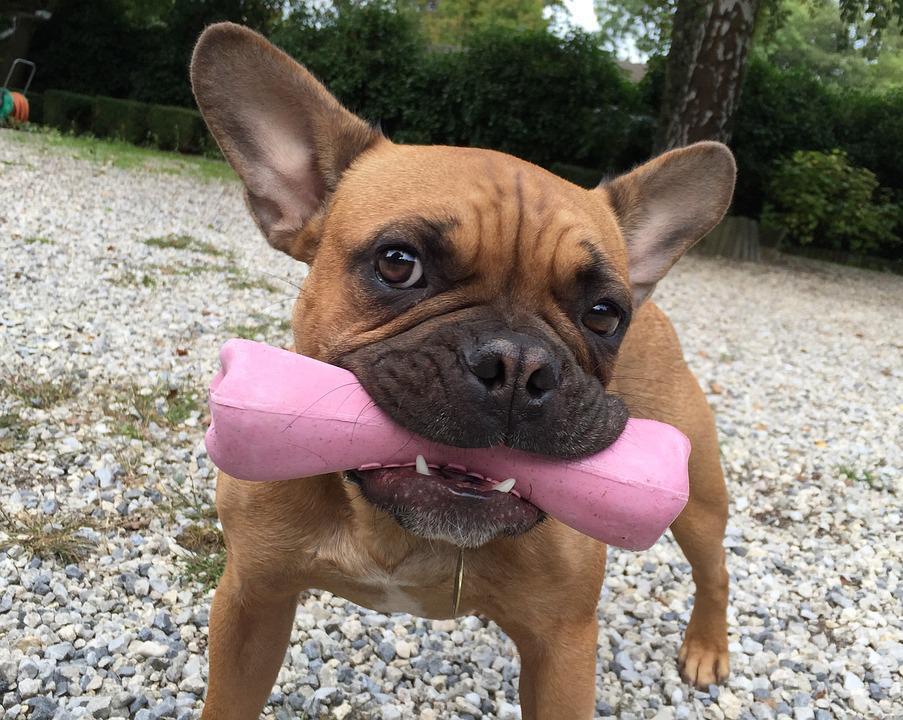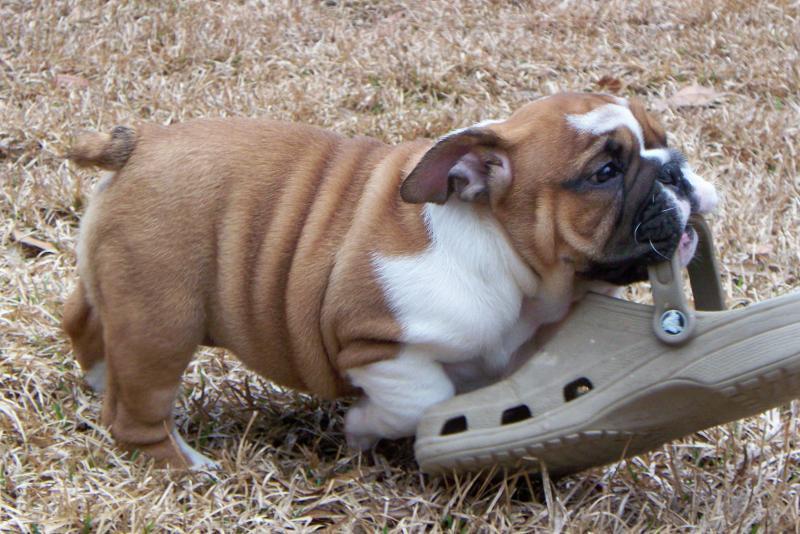The first image is the image on the left, the second image is the image on the right. Evaluate the accuracy of this statement regarding the images: "One image shows a tan big-eared dog standing with its body turned forward and holding a solid-colored toy in its mouth.". Is it true? Answer yes or no. Yes. The first image is the image on the left, the second image is the image on the right. For the images displayed, is the sentence "The right image contains at least two dogs." factually correct? Answer yes or no. No. 